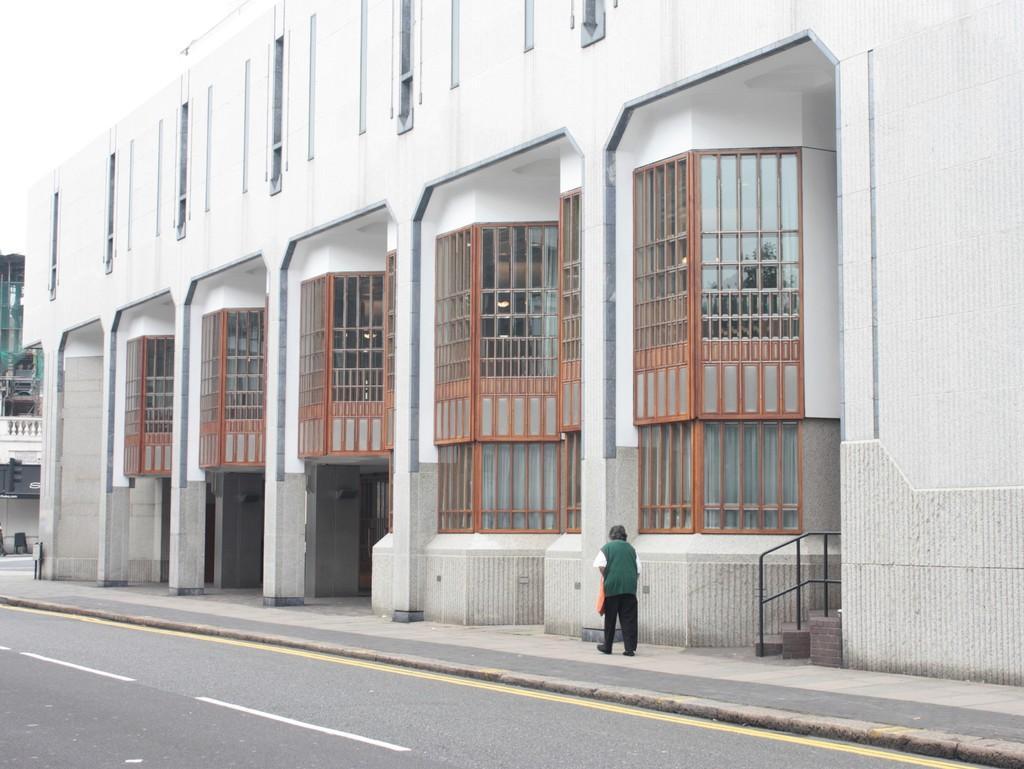Can you describe this image briefly? In this picture there is a building which is in white color and there is a person standing beside it and there is another building in the background. 